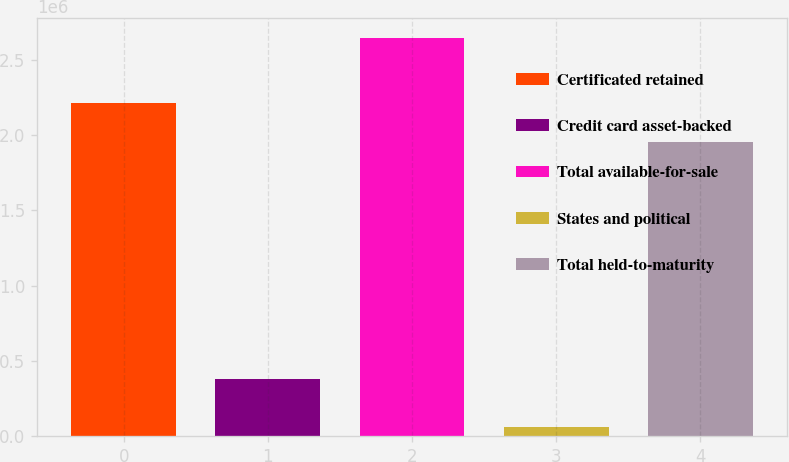Convert chart to OTSL. <chart><loc_0><loc_0><loc_500><loc_500><bar_chart><fcel>Certificated retained<fcel>Credit card asset-backed<fcel>Total available-for-sale<fcel>States and political<fcel>Total held-to-maturity<nl><fcel>2.2123e+06<fcel>381705<fcel>2.64548e+06<fcel>62410<fcel>1.95399e+06<nl></chart> 